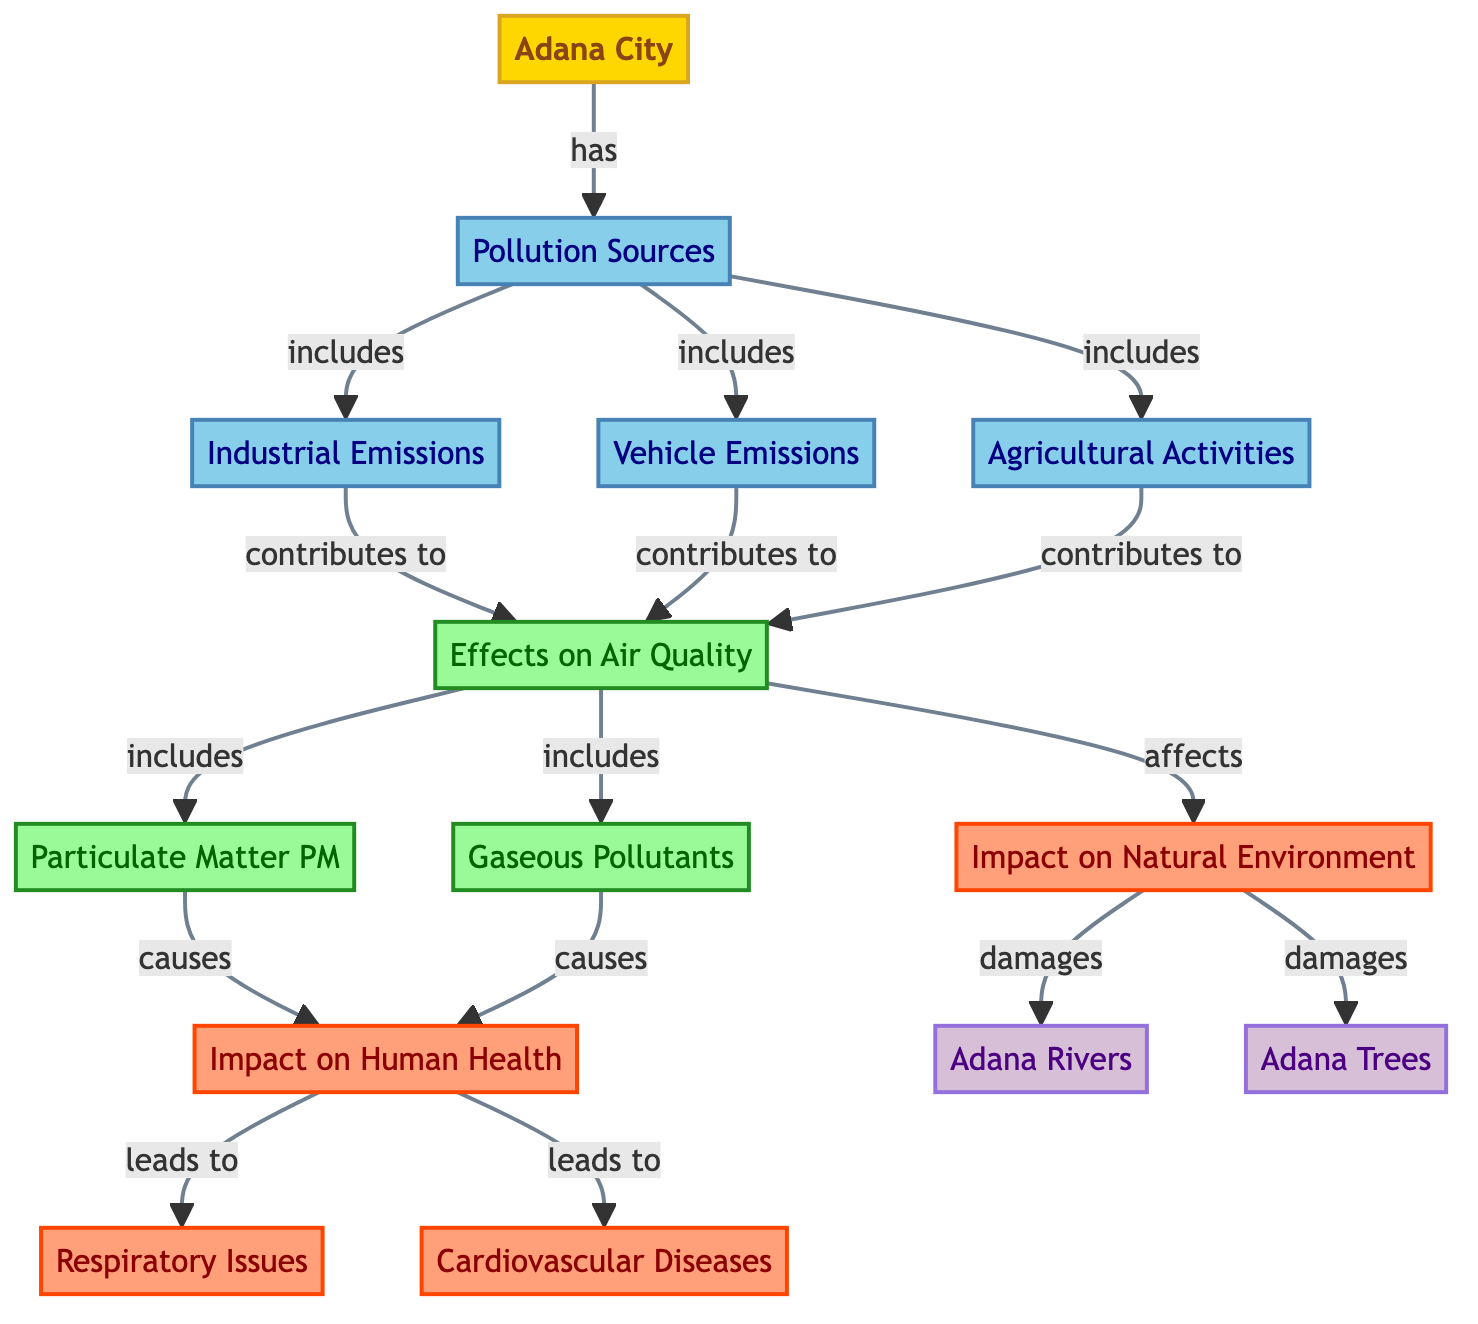What are the pollution sources listed in the diagram? The pollution sources are represented by nodes labeled "Pollution Sources," which includes "Industrial Emissions," "Vehicle Emissions," and "Agricultural Activities." Counting these nodes gives us three specific pollution sources.
Answer: Industrial Emissions, Vehicle Emissions, Agricultural Activities What is the main impact of pollution on air quality? The diagram indicates that "Effects on Air Quality" encompasses two specific types, namely "Particulate Matter PM" and "Gaseous Pollutants." This section specifically points to the adverse effects of pollution.
Answer: Particulate Matter PM, Gaseous Pollutants What health issues does air pollution cause according to the diagram? The nodes under "Impact on Human Health" specify two major health issues linked to pollution: "Respiratory Issues" and "Cardiovascular Diseases." Therefore, these are the health concerns highlighted.
Answer: Respiratory Issues, Cardiovascular Diseases How many nodes are there related to the natural environment? The natural environment is represented by two nodes: "Adana Rivers" and "Adana Trees." Therefore, there are two nodes concerning the natural environment in the diagram.
Answer: 2 Which node directly affects the natural environment? The diagram shows that the "Effects on Air Quality" node directly connects to the "Impact on Natural Environment" node, leading to damage on "Adana Rivers" and "Adana Trees." Hence, effects on air quality is the influencing factor.
Answer: Effects on Air Quality What does the node "Adana City" connect to? The node "Adana City" is directly connected to "Pollution Sources," indicating that the city experiences pollution originating from various sources identified in the diagram.
Answer: Pollution Sources What types of pollutants are included in the effects on air quality? The diagram specifies that "Effects on Air Quality" includes "Particulate Matter PM" and "Gaseous Pollutants." Thus, these types of pollutants are mentioned accordingly.
Answer: Particulate Matter PM, Gaseous Pollutants What is the overall impact of air quality on health issues? According to the flow in the diagram, "Effects on Air Quality" causes the "Impact on Human Health," which leads to issues like "Respiratory Issues" and "Cardiovascular Diseases." The overall relationship shows the consequential nature of pollution affecting health.
Answer: Impact on Human Health What are the two branches of impact on the natural environment? The "Impact on Natural Environment" node has two branches leading to "Adana Rivers" and "Adana Trees," illustrating the specific areas affected by pollution. Therefore, both these elements are highlighted as impacted.
Answer: Adana Rivers, Adana Trees 